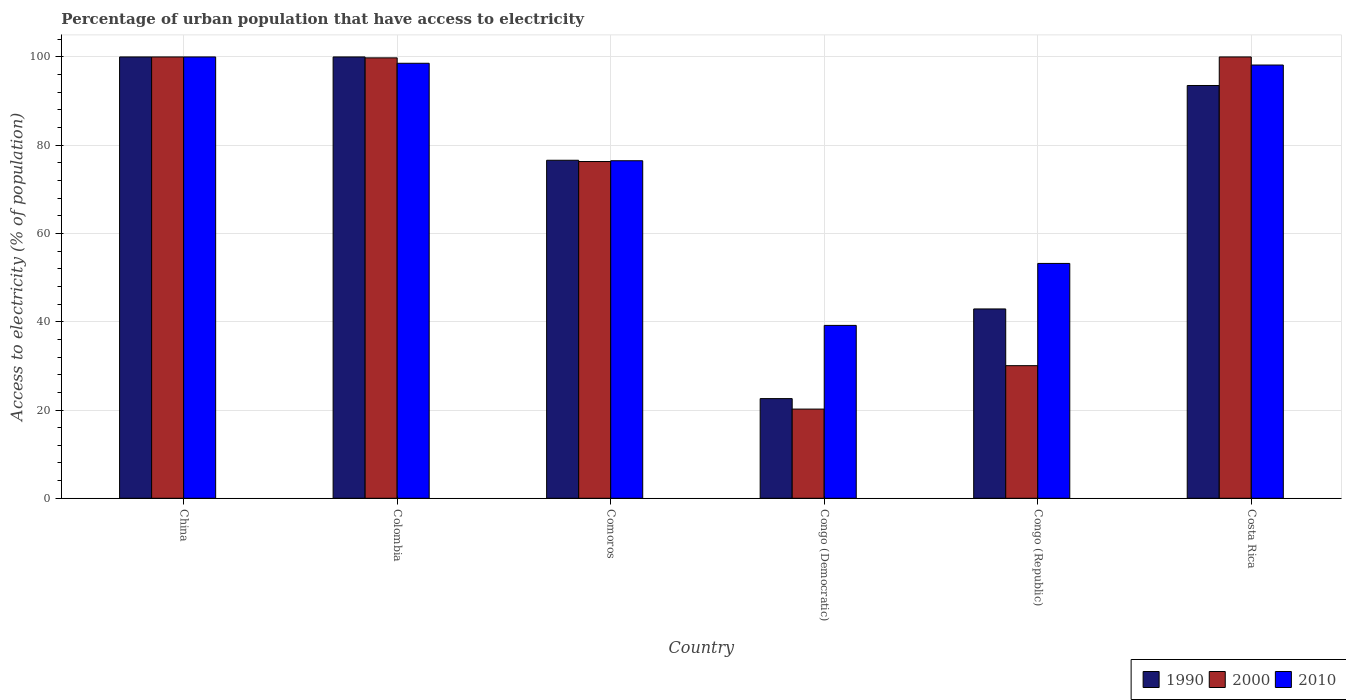How many groups of bars are there?
Offer a very short reply. 6. Are the number of bars per tick equal to the number of legend labels?
Your response must be concise. Yes. How many bars are there on the 6th tick from the right?
Your answer should be very brief. 3. What is the label of the 6th group of bars from the left?
Your response must be concise. Costa Rica. In how many cases, is the number of bars for a given country not equal to the number of legend labels?
Give a very brief answer. 0. What is the percentage of urban population that have access to electricity in 1990 in Comoros?
Your answer should be very brief. 76.59. Across all countries, what is the minimum percentage of urban population that have access to electricity in 2010?
Give a very brief answer. 39.17. In which country was the percentage of urban population that have access to electricity in 2000 maximum?
Offer a terse response. China. In which country was the percentage of urban population that have access to electricity in 1990 minimum?
Your answer should be very brief. Congo (Democratic). What is the total percentage of urban population that have access to electricity in 2010 in the graph?
Offer a terse response. 465.6. What is the difference between the percentage of urban population that have access to electricity in 1990 in China and that in Congo (Democratic)?
Make the answer very short. 77.42. What is the difference between the percentage of urban population that have access to electricity in 2000 in Comoros and the percentage of urban population that have access to electricity in 1990 in Congo (Republic)?
Give a very brief answer. 33.4. What is the average percentage of urban population that have access to electricity in 2010 per country?
Give a very brief answer. 77.6. What is the difference between the percentage of urban population that have access to electricity of/in 2010 and percentage of urban population that have access to electricity of/in 2000 in Congo (Republic)?
Your answer should be compact. 23.16. In how many countries, is the percentage of urban population that have access to electricity in 1990 greater than 56 %?
Make the answer very short. 4. What is the ratio of the percentage of urban population that have access to electricity in 1990 in Congo (Democratic) to that in Congo (Republic)?
Provide a succinct answer. 0.53. What is the difference between the highest and the second highest percentage of urban population that have access to electricity in 1990?
Your response must be concise. 6.47. What is the difference between the highest and the lowest percentage of urban population that have access to electricity in 2010?
Provide a succinct answer. 60.83. Is the sum of the percentage of urban population that have access to electricity in 2010 in Colombia and Comoros greater than the maximum percentage of urban population that have access to electricity in 2000 across all countries?
Give a very brief answer. Yes. What does the 3rd bar from the right in Colombia represents?
Your response must be concise. 1990. Is it the case that in every country, the sum of the percentage of urban population that have access to electricity in 1990 and percentage of urban population that have access to electricity in 2010 is greater than the percentage of urban population that have access to electricity in 2000?
Your answer should be very brief. Yes. Are all the bars in the graph horizontal?
Your response must be concise. No. How many countries are there in the graph?
Your response must be concise. 6. What is the difference between two consecutive major ticks on the Y-axis?
Offer a terse response. 20. Does the graph contain any zero values?
Offer a terse response. No. What is the title of the graph?
Keep it short and to the point. Percentage of urban population that have access to electricity. What is the label or title of the X-axis?
Your answer should be very brief. Country. What is the label or title of the Y-axis?
Offer a terse response. Access to electricity (% of population). What is the Access to electricity (% of population) of 2010 in China?
Provide a short and direct response. 100. What is the Access to electricity (% of population) in 2000 in Colombia?
Your response must be concise. 99.79. What is the Access to electricity (% of population) of 2010 in Colombia?
Offer a very short reply. 98.56. What is the Access to electricity (% of population) in 1990 in Comoros?
Make the answer very short. 76.59. What is the Access to electricity (% of population) of 2000 in Comoros?
Make the answer very short. 76.3. What is the Access to electricity (% of population) in 2010 in Comoros?
Give a very brief answer. 76.48. What is the Access to electricity (% of population) of 1990 in Congo (Democratic)?
Your response must be concise. 22.58. What is the Access to electricity (% of population) in 2000 in Congo (Democratic)?
Your answer should be very brief. 20.21. What is the Access to electricity (% of population) of 2010 in Congo (Democratic)?
Provide a succinct answer. 39.17. What is the Access to electricity (% of population) of 1990 in Congo (Republic)?
Your response must be concise. 42.9. What is the Access to electricity (% of population) of 2000 in Congo (Republic)?
Make the answer very short. 30.05. What is the Access to electricity (% of population) of 2010 in Congo (Republic)?
Your response must be concise. 53.21. What is the Access to electricity (% of population) in 1990 in Costa Rica?
Offer a terse response. 93.53. What is the Access to electricity (% of population) of 2010 in Costa Rica?
Make the answer very short. 98.17. Across all countries, what is the minimum Access to electricity (% of population) in 1990?
Make the answer very short. 22.58. Across all countries, what is the minimum Access to electricity (% of population) of 2000?
Keep it short and to the point. 20.21. Across all countries, what is the minimum Access to electricity (% of population) in 2010?
Offer a very short reply. 39.17. What is the total Access to electricity (% of population) of 1990 in the graph?
Provide a short and direct response. 435.61. What is the total Access to electricity (% of population) of 2000 in the graph?
Make the answer very short. 426.35. What is the total Access to electricity (% of population) in 2010 in the graph?
Your answer should be compact. 465.6. What is the difference between the Access to electricity (% of population) of 2000 in China and that in Colombia?
Provide a succinct answer. 0.21. What is the difference between the Access to electricity (% of population) of 2010 in China and that in Colombia?
Provide a short and direct response. 1.44. What is the difference between the Access to electricity (% of population) in 1990 in China and that in Comoros?
Offer a very short reply. 23.41. What is the difference between the Access to electricity (% of population) of 2000 in China and that in Comoros?
Give a very brief answer. 23.7. What is the difference between the Access to electricity (% of population) of 2010 in China and that in Comoros?
Provide a short and direct response. 23.52. What is the difference between the Access to electricity (% of population) of 1990 in China and that in Congo (Democratic)?
Ensure brevity in your answer.  77.42. What is the difference between the Access to electricity (% of population) of 2000 in China and that in Congo (Democratic)?
Give a very brief answer. 79.79. What is the difference between the Access to electricity (% of population) in 2010 in China and that in Congo (Democratic)?
Give a very brief answer. 60.83. What is the difference between the Access to electricity (% of population) of 1990 in China and that in Congo (Republic)?
Your answer should be very brief. 57.1. What is the difference between the Access to electricity (% of population) of 2000 in China and that in Congo (Republic)?
Provide a succinct answer. 69.95. What is the difference between the Access to electricity (% of population) of 2010 in China and that in Congo (Republic)?
Ensure brevity in your answer.  46.79. What is the difference between the Access to electricity (% of population) of 1990 in China and that in Costa Rica?
Your answer should be very brief. 6.47. What is the difference between the Access to electricity (% of population) in 2000 in China and that in Costa Rica?
Make the answer very short. 0. What is the difference between the Access to electricity (% of population) of 2010 in China and that in Costa Rica?
Keep it short and to the point. 1.83. What is the difference between the Access to electricity (% of population) of 1990 in Colombia and that in Comoros?
Provide a succinct answer. 23.41. What is the difference between the Access to electricity (% of population) in 2000 in Colombia and that in Comoros?
Your answer should be very brief. 23.49. What is the difference between the Access to electricity (% of population) of 2010 in Colombia and that in Comoros?
Offer a very short reply. 22.08. What is the difference between the Access to electricity (% of population) of 1990 in Colombia and that in Congo (Democratic)?
Your response must be concise. 77.42. What is the difference between the Access to electricity (% of population) of 2000 in Colombia and that in Congo (Democratic)?
Provide a succinct answer. 79.58. What is the difference between the Access to electricity (% of population) of 2010 in Colombia and that in Congo (Democratic)?
Make the answer very short. 59.39. What is the difference between the Access to electricity (% of population) in 1990 in Colombia and that in Congo (Republic)?
Your answer should be compact. 57.1. What is the difference between the Access to electricity (% of population) in 2000 in Colombia and that in Congo (Republic)?
Provide a short and direct response. 69.74. What is the difference between the Access to electricity (% of population) of 2010 in Colombia and that in Congo (Republic)?
Provide a short and direct response. 45.35. What is the difference between the Access to electricity (% of population) of 1990 in Colombia and that in Costa Rica?
Provide a short and direct response. 6.47. What is the difference between the Access to electricity (% of population) of 2000 in Colombia and that in Costa Rica?
Ensure brevity in your answer.  -0.21. What is the difference between the Access to electricity (% of population) in 2010 in Colombia and that in Costa Rica?
Keep it short and to the point. 0.4. What is the difference between the Access to electricity (% of population) in 1990 in Comoros and that in Congo (Democratic)?
Keep it short and to the point. 54.01. What is the difference between the Access to electricity (% of population) of 2000 in Comoros and that in Congo (Democratic)?
Your response must be concise. 56.09. What is the difference between the Access to electricity (% of population) of 2010 in Comoros and that in Congo (Democratic)?
Your response must be concise. 37.31. What is the difference between the Access to electricity (% of population) in 1990 in Comoros and that in Congo (Republic)?
Provide a short and direct response. 33.69. What is the difference between the Access to electricity (% of population) in 2000 in Comoros and that in Congo (Republic)?
Provide a short and direct response. 46.26. What is the difference between the Access to electricity (% of population) in 2010 in Comoros and that in Congo (Republic)?
Give a very brief answer. 23.27. What is the difference between the Access to electricity (% of population) of 1990 in Comoros and that in Costa Rica?
Your answer should be compact. -16.94. What is the difference between the Access to electricity (% of population) in 2000 in Comoros and that in Costa Rica?
Give a very brief answer. -23.7. What is the difference between the Access to electricity (% of population) of 2010 in Comoros and that in Costa Rica?
Offer a terse response. -21.69. What is the difference between the Access to electricity (% of population) of 1990 in Congo (Democratic) and that in Congo (Republic)?
Make the answer very short. -20.32. What is the difference between the Access to electricity (% of population) of 2000 in Congo (Democratic) and that in Congo (Republic)?
Provide a succinct answer. -9.84. What is the difference between the Access to electricity (% of population) of 2010 in Congo (Democratic) and that in Congo (Republic)?
Your response must be concise. -14.04. What is the difference between the Access to electricity (% of population) in 1990 in Congo (Democratic) and that in Costa Rica?
Keep it short and to the point. -70.95. What is the difference between the Access to electricity (% of population) in 2000 in Congo (Democratic) and that in Costa Rica?
Give a very brief answer. -79.79. What is the difference between the Access to electricity (% of population) in 2010 in Congo (Democratic) and that in Costa Rica?
Make the answer very short. -58.99. What is the difference between the Access to electricity (% of population) of 1990 in Congo (Republic) and that in Costa Rica?
Your response must be concise. -50.63. What is the difference between the Access to electricity (% of population) in 2000 in Congo (Republic) and that in Costa Rica?
Your response must be concise. -69.95. What is the difference between the Access to electricity (% of population) in 2010 in Congo (Republic) and that in Costa Rica?
Provide a succinct answer. -44.95. What is the difference between the Access to electricity (% of population) of 1990 in China and the Access to electricity (% of population) of 2000 in Colombia?
Provide a succinct answer. 0.21. What is the difference between the Access to electricity (% of population) of 1990 in China and the Access to electricity (% of population) of 2010 in Colombia?
Keep it short and to the point. 1.44. What is the difference between the Access to electricity (% of population) in 2000 in China and the Access to electricity (% of population) in 2010 in Colombia?
Keep it short and to the point. 1.44. What is the difference between the Access to electricity (% of population) of 1990 in China and the Access to electricity (% of population) of 2000 in Comoros?
Make the answer very short. 23.7. What is the difference between the Access to electricity (% of population) of 1990 in China and the Access to electricity (% of population) of 2010 in Comoros?
Your answer should be compact. 23.52. What is the difference between the Access to electricity (% of population) of 2000 in China and the Access to electricity (% of population) of 2010 in Comoros?
Keep it short and to the point. 23.52. What is the difference between the Access to electricity (% of population) of 1990 in China and the Access to electricity (% of population) of 2000 in Congo (Democratic)?
Make the answer very short. 79.79. What is the difference between the Access to electricity (% of population) of 1990 in China and the Access to electricity (% of population) of 2010 in Congo (Democratic)?
Keep it short and to the point. 60.83. What is the difference between the Access to electricity (% of population) of 2000 in China and the Access to electricity (% of population) of 2010 in Congo (Democratic)?
Your answer should be very brief. 60.83. What is the difference between the Access to electricity (% of population) in 1990 in China and the Access to electricity (% of population) in 2000 in Congo (Republic)?
Offer a very short reply. 69.95. What is the difference between the Access to electricity (% of population) of 1990 in China and the Access to electricity (% of population) of 2010 in Congo (Republic)?
Provide a short and direct response. 46.79. What is the difference between the Access to electricity (% of population) of 2000 in China and the Access to electricity (% of population) of 2010 in Congo (Republic)?
Ensure brevity in your answer.  46.79. What is the difference between the Access to electricity (% of population) in 1990 in China and the Access to electricity (% of population) in 2000 in Costa Rica?
Your answer should be compact. 0. What is the difference between the Access to electricity (% of population) in 1990 in China and the Access to electricity (% of population) in 2010 in Costa Rica?
Provide a succinct answer. 1.83. What is the difference between the Access to electricity (% of population) of 2000 in China and the Access to electricity (% of population) of 2010 in Costa Rica?
Your answer should be compact. 1.83. What is the difference between the Access to electricity (% of population) in 1990 in Colombia and the Access to electricity (% of population) in 2000 in Comoros?
Keep it short and to the point. 23.7. What is the difference between the Access to electricity (% of population) in 1990 in Colombia and the Access to electricity (% of population) in 2010 in Comoros?
Provide a short and direct response. 23.52. What is the difference between the Access to electricity (% of population) of 2000 in Colombia and the Access to electricity (% of population) of 2010 in Comoros?
Keep it short and to the point. 23.31. What is the difference between the Access to electricity (% of population) in 1990 in Colombia and the Access to electricity (% of population) in 2000 in Congo (Democratic)?
Offer a very short reply. 79.79. What is the difference between the Access to electricity (% of population) of 1990 in Colombia and the Access to electricity (% of population) of 2010 in Congo (Democratic)?
Offer a terse response. 60.83. What is the difference between the Access to electricity (% of population) of 2000 in Colombia and the Access to electricity (% of population) of 2010 in Congo (Democratic)?
Offer a terse response. 60.62. What is the difference between the Access to electricity (% of population) of 1990 in Colombia and the Access to electricity (% of population) of 2000 in Congo (Republic)?
Your answer should be very brief. 69.95. What is the difference between the Access to electricity (% of population) of 1990 in Colombia and the Access to electricity (% of population) of 2010 in Congo (Republic)?
Your response must be concise. 46.79. What is the difference between the Access to electricity (% of population) of 2000 in Colombia and the Access to electricity (% of population) of 2010 in Congo (Republic)?
Offer a very short reply. 46.58. What is the difference between the Access to electricity (% of population) in 1990 in Colombia and the Access to electricity (% of population) in 2000 in Costa Rica?
Ensure brevity in your answer.  0. What is the difference between the Access to electricity (% of population) of 1990 in Colombia and the Access to electricity (% of population) of 2010 in Costa Rica?
Offer a terse response. 1.83. What is the difference between the Access to electricity (% of population) of 2000 in Colombia and the Access to electricity (% of population) of 2010 in Costa Rica?
Keep it short and to the point. 1.62. What is the difference between the Access to electricity (% of population) of 1990 in Comoros and the Access to electricity (% of population) of 2000 in Congo (Democratic)?
Your answer should be very brief. 56.38. What is the difference between the Access to electricity (% of population) of 1990 in Comoros and the Access to electricity (% of population) of 2010 in Congo (Democratic)?
Provide a short and direct response. 37.42. What is the difference between the Access to electricity (% of population) in 2000 in Comoros and the Access to electricity (% of population) in 2010 in Congo (Democratic)?
Provide a succinct answer. 37.13. What is the difference between the Access to electricity (% of population) in 1990 in Comoros and the Access to electricity (% of population) in 2000 in Congo (Republic)?
Offer a very short reply. 46.54. What is the difference between the Access to electricity (% of population) in 1990 in Comoros and the Access to electricity (% of population) in 2010 in Congo (Republic)?
Provide a succinct answer. 23.38. What is the difference between the Access to electricity (% of population) of 2000 in Comoros and the Access to electricity (% of population) of 2010 in Congo (Republic)?
Your answer should be compact. 23.09. What is the difference between the Access to electricity (% of population) of 1990 in Comoros and the Access to electricity (% of population) of 2000 in Costa Rica?
Keep it short and to the point. -23.41. What is the difference between the Access to electricity (% of population) of 1990 in Comoros and the Access to electricity (% of population) of 2010 in Costa Rica?
Offer a terse response. -21.58. What is the difference between the Access to electricity (% of population) in 2000 in Comoros and the Access to electricity (% of population) in 2010 in Costa Rica?
Give a very brief answer. -21.86. What is the difference between the Access to electricity (% of population) of 1990 in Congo (Democratic) and the Access to electricity (% of population) of 2000 in Congo (Republic)?
Make the answer very short. -7.46. What is the difference between the Access to electricity (% of population) of 1990 in Congo (Democratic) and the Access to electricity (% of population) of 2010 in Congo (Republic)?
Ensure brevity in your answer.  -30.63. What is the difference between the Access to electricity (% of population) in 2000 in Congo (Democratic) and the Access to electricity (% of population) in 2010 in Congo (Republic)?
Keep it short and to the point. -33. What is the difference between the Access to electricity (% of population) of 1990 in Congo (Democratic) and the Access to electricity (% of population) of 2000 in Costa Rica?
Your response must be concise. -77.42. What is the difference between the Access to electricity (% of population) in 1990 in Congo (Democratic) and the Access to electricity (% of population) in 2010 in Costa Rica?
Give a very brief answer. -75.58. What is the difference between the Access to electricity (% of population) in 2000 in Congo (Democratic) and the Access to electricity (% of population) in 2010 in Costa Rica?
Offer a terse response. -77.96. What is the difference between the Access to electricity (% of population) of 1990 in Congo (Republic) and the Access to electricity (% of population) of 2000 in Costa Rica?
Ensure brevity in your answer.  -57.1. What is the difference between the Access to electricity (% of population) in 1990 in Congo (Republic) and the Access to electricity (% of population) in 2010 in Costa Rica?
Offer a terse response. -55.27. What is the difference between the Access to electricity (% of population) in 2000 in Congo (Republic) and the Access to electricity (% of population) in 2010 in Costa Rica?
Make the answer very short. -68.12. What is the average Access to electricity (% of population) in 1990 per country?
Make the answer very short. 72.6. What is the average Access to electricity (% of population) of 2000 per country?
Your answer should be very brief. 71.06. What is the average Access to electricity (% of population) of 2010 per country?
Ensure brevity in your answer.  77.6. What is the difference between the Access to electricity (% of population) of 1990 and Access to electricity (% of population) of 2010 in China?
Ensure brevity in your answer.  0. What is the difference between the Access to electricity (% of population) in 1990 and Access to electricity (% of population) in 2000 in Colombia?
Provide a short and direct response. 0.21. What is the difference between the Access to electricity (% of population) in 1990 and Access to electricity (% of population) in 2010 in Colombia?
Your answer should be compact. 1.44. What is the difference between the Access to electricity (% of population) of 2000 and Access to electricity (% of population) of 2010 in Colombia?
Keep it short and to the point. 1.22. What is the difference between the Access to electricity (% of population) of 1990 and Access to electricity (% of population) of 2000 in Comoros?
Ensure brevity in your answer.  0.29. What is the difference between the Access to electricity (% of population) in 1990 and Access to electricity (% of population) in 2010 in Comoros?
Your answer should be very brief. 0.11. What is the difference between the Access to electricity (% of population) in 2000 and Access to electricity (% of population) in 2010 in Comoros?
Your response must be concise. -0.18. What is the difference between the Access to electricity (% of population) in 1990 and Access to electricity (% of population) in 2000 in Congo (Democratic)?
Your answer should be compact. 2.37. What is the difference between the Access to electricity (% of population) in 1990 and Access to electricity (% of population) in 2010 in Congo (Democratic)?
Offer a terse response. -16.59. What is the difference between the Access to electricity (% of population) in 2000 and Access to electricity (% of population) in 2010 in Congo (Democratic)?
Your response must be concise. -18.96. What is the difference between the Access to electricity (% of population) in 1990 and Access to electricity (% of population) in 2000 in Congo (Republic)?
Your response must be concise. 12.85. What is the difference between the Access to electricity (% of population) of 1990 and Access to electricity (% of population) of 2010 in Congo (Republic)?
Ensure brevity in your answer.  -10.31. What is the difference between the Access to electricity (% of population) of 2000 and Access to electricity (% of population) of 2010 in Congo (Republic)?
Keep it short and to the point. -23.16. What is the difference between the Access to electricity (% of population) of 1990 and Access to electricity (% of population) of 2000 in Costa Rica?
Offer a very short reply. -6.47. What is the difference between the Access to electricity (% of population) in 1990 and Access to electricity (% of population) in 2010 in Costa Rica?
Provide a short and direct response. -4.64. What is the difference between the Access to electricity (% of population) in 2000 and Access to electricity (% of population) in 2010 in Costa Rica?
Make the answer very short. 1.83. What is the ratio of the Access to electricity (% of population) of 1990 in China to that in Colombia?
Provide a short and direct response. 1. What is the ratio of the Access to electricity (% of population) of 2000 in China to that in Colombia?
Offer a very short reply. 1. What is the ratio of the Access to electricity (% of population) in 2010 in China to that in Colombia?
Your answer should be compact. 1.01. What is the ratio of the Access to electricity (% of population) in 1990 in China to that in Comoros?
Offer a very short reply. 1.31. What is the ratio of the Access to electricity (% of population) in 2000 in China to that in Comoros?
Keep it short and to the point. 1.31. What is the ratio of the Access to electricity (% of population) in 2010 in China to that in Comoros?
Offer a terse response. 1.31. What is the ratio of the Access to electricity (% of population) in 1990 in China to that in Congo (Democratic)?
Provide a succinct answer. 4.43. What is the ratio of the Access to electricity (% of population) in 2000 in China to that in Congo (Democratic)?
Give a very brief answer. 4.95. What is the ratio of the Access to electricity (% of population) of 2010 in China to that in Congo (Democratic)?
Keep it short and to the point. 2.55. What is the ratio of the Access to electricity (% of population) in 1990 in China to that in Congo (Republic)?
Give a very brief answer. 2.33. What is the ratio of the Access to electricity (% of population) of 2000 in China to that in Congo (Republic)?
Provide a short and direct response. 3.33. What is the ratio of the Access to electricity (% of population) in 2010 in China to that in Congo (Republic)?
Make the answer very short. 1.88. What is the ratio of the Access to electricity (% of population) in 1990 in China to that in Costa Rica?
Offer a terse response. 1.07. What is the ratio of the Access to electricity (% of population) of 2000 in China to that in Costa Rica?
Your answer should be compact. 1. What is the ratio of the Access to electricity (% of population) in 2010 in China to that in Costa Rica?
Give a very brief answer. 1.02. What is the ratio of the Access to electricity (% of population) in 1990 in Colombia to that in Comoros?
Ensure brevity in your answer.  1.31. What is the ratio of the Access to electricity (% of population) of 2000 in Colombia to that in Comoros?
Offer a very short reply. 1.31. What is the ratio of the Access to electricity (% of population) of 2010 in Colombia to that in Comoros?
Provide a succinct answer. 1.29. What is the ratio of the Access to electricity (% of population) in 1990 in Colombia to that in Congo (Democratic)?
Offer a terse response. 4.43. What is the ratio of the Access to electricity (% of population) of 2000 in Colombia to that in Congo (Democratic)?
Your answer should be compact. 4.94. What is the ratio of the Access to electricity (% of population) in 2010 in Colombia to that in Congo (Democratic)?
Your response must be concise. 2.52. What is the ratio of the Access to electricity (% of population) of 1990 in Colombia to that in Congo (Republic)?
Your answer should be very brief. 2.33. What is the ratio of the Access to electricity (% of population) of 2000 in Colombia to that in Congo (Republic)?
Your answer should be very brief. 3.32. What is the ratio of the Access to electricity (% of population) of 2010 in Colombia to that in Congo (Republic)?
Provide a succinct answer. 1.85. What is the ratio of the Access to electricity (% of population) of 1990 in Colombia to that in Costa Rica?
Offer a very short reply. 1.07. What is the ratio of the Access to electricity (% of population) in 2000 in Colombia to that in Costa Rica?
Your answer should be very brief. 1. What is the ratio of the Access to electricity (% of population) in 2010 in Colombia to that in Costa Rica?
Keep it short and to the point. 1. What is the ratio of the Access to electricity (% of population) of 1990 in Comoros to that in Congo (Democratic)?
Your answer should be compact. 3.39. What is the ratio of the Access to electricity (% of population) of 2000 in Comoros to that in Congo (Democratic)?
Provide a short and direct response. 3.78. What is the ratio of the Access to electricity (% of population) of 2010 in Comoros to that in Congo (Democratic)?
Ensure brevity in your answer.  1.95. What is the ratio of the Access to electricity (% of population) of 1990 in Comoros to that in Congo (Republic)?
Your answer should be compact. 1.79. What is the ratio of the Access to electricity (% of population) of 2000 in Comoros to that in Congo (Republic)?
Ensure brevity in your answer.  2.54. What is the ratio of the Access to electricity (% of population) of 2010 in Comoros to that in Congo (Republic)?
Provide a succinct answer. 1.44. What is the ratio of the Access to electricity (% of population) in 1990 in Comoros to that in Costa Rica?
Your answer should be compact. 0.82. What is the ratio of the Access to electricity (% of population) of 2000 in Comoros to that in Costa Rica?
Your answer should be compact. 0.76. What is the ratio of the Access to electricity (% of population) in 2010 in Comoros to that in Costa Rica?
Your answer should be very brief. 0.78. What is the ratio of the Access to electricity (% of population) of 1990 in Congo (Democratic) to that in Congo (Republic)?
Offer a terse response. 0.53. What is the ratio of the Access to electricity (% of population) in 2000 in Congo (Democratic) to that in Congo (Republic)?
Offer a very short reply. 0.67. What is the ratio of the Access to electricity (% of population) of 2010 in Congo (Democratic) to that in Congo (Republic)?
Your answer should be very brief. 0.74. What is the ratio of the Access to electricity (% of population) of 1990 in Congo (Democratic) to that in Costa Rica?
Your answer should be very brief. 0.24. What is the ratio of the Access to electricity (% of population) in 2000 in Congo (Democratic) to that in Costa Rica?
Your response must be concise. 0.2. What is the ratio of the Access to electricity (% of population) in 2010 in Congo (Democratic) to that in Costa Rica?
Keep it short and to the point. 0.4. What is the ratio of the Access to electricity (% of population) in 1990 in Congo (Republic) to that in Costa Rica?
Provide a short and direct response. 0.46. What is the ratio of the Access to electricity (% of population) of 2000 in Congo (Republic) to that in Costa Rica?
Offer a very short reply. 0.3. What is the ratio of the Access to electricity (% of population) in 2010 in Congo (Republic) to that in Costa Rica?
Keep it short and to the point. 0.54. What is the difference between the highest and the second highest Access to electricity (% of population) of 2000?
Your response must be concise. 0. What is the difference between the highest and the second highest Access to electricity (% of population) of 2010?
Keep it short and to the point. 1.44. What is the difference between the highest and the lowest Access to electricity (% of population) in 1990?
Give a very brief answer. 77.42. What is the difference between the highest and the lowest Access to electricity (% of population) of 2000?
Keep it short and to the point. 79.79. What is the difference between the highest and the lowest Access to electricity (% of population) of 2010?
Provide a succinct answer. 60.83. 